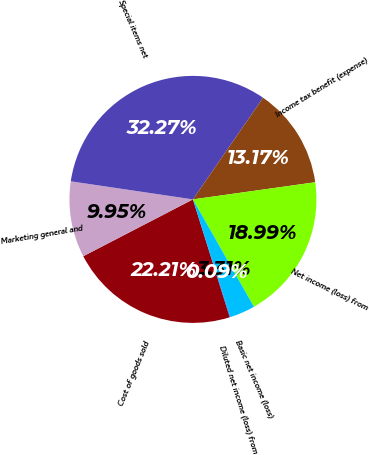<chart> <loc_0><loc_0><loc_500><loc_500><pie_chart><fcel>Cost of goods sold<fcel>Marketing general and<fcel>Special items net<fcel>Income tax benefit (expense)<fcel>Net income (loss) from<fcel>Basic net income (loss)<fcel>Diluted net income (loss) from<nl><fcel>22.21%<fcel>9.95%<fcel>32.27%<fcel>13.17%<fcel>18.99%<fcel>3.31%<fcel>0.09%<nl></chart> 